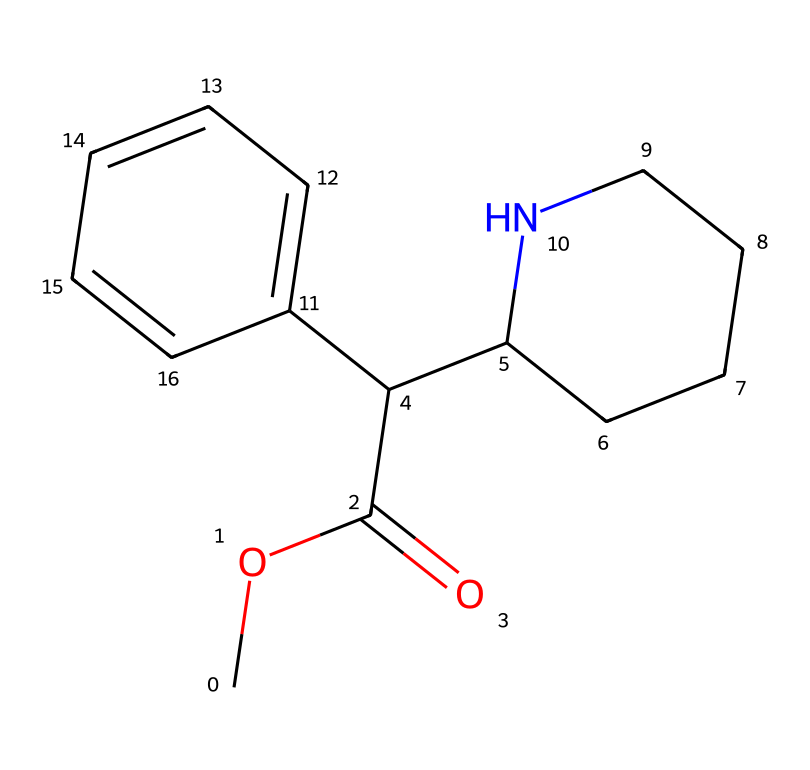What is the name of this chemical? The chemical structure corresponds to methylphenidate, which is commonly known by the brand name Ritalin and is used in ADHD treatment.
Answer: methylphenidate How many nitrogen atoms are present in this molecule? Analyzing the SMILES representation, there is one nitrogen atom present in the side chain (C1CCCCN1).
Answer: one What is the molecular formula of methylphenidate? To derive the molecular formula, we can count the atoms in the SMILES: Carbon = 17, Hydrogen = 19, Nitrogen = 1, Oxygen = 2, which gives us C17H19N1O2.
Answer: C17H19N1O2 What type of functional groups are present in this structure? Looking at the structure, there is an ester functional group (due to COC(=O)) and an aromatic ring (C2=CC=CC=C2) which indicates phenolic properties.
Answer: ester, aromatic How many rings are present in the overall structure? The structure has one aromatic ring in the phenyl group and one five-membered cyclic amine (pyrrolidine) backbone, totaling two rings.
Answer: two Is this chemical hydrophilic or hydrophobic? Considering the presence of the ester group and the non-polar hydrocarbon regions, methylphenidate is generally considered slightly hydrophobic with some amphiphilic characteristics.
Answer: hydrophobic What potential effects does this chemical target in the human body? Methylphenidate primarily acts as a central nervous system stimulant, targeting neurotransmitter systems, specifically dopamine and norepinephrine pathways to enhance attention and focus.
Answer: stimulant 